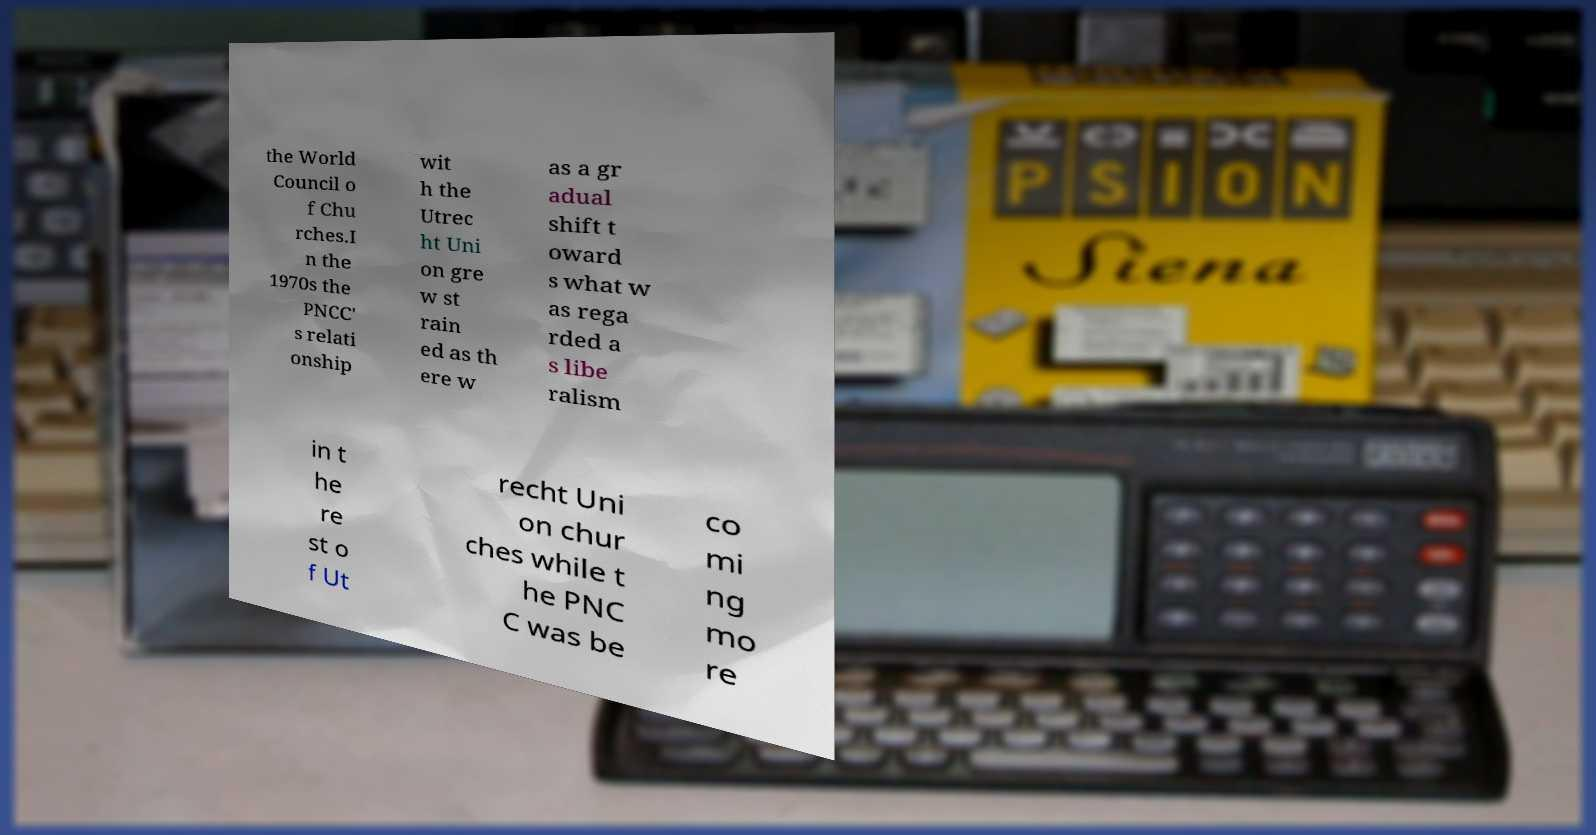For documentation purposes, I need the text within this image transcribed. Could you provide that? the World Council o f Chu rches.I n the 1970s the PNCC' s relati onship wit h the Utrec ht Uni on gre w st rain ed as th ere w as a gr adual shift t oward s what w as rega rded a s libe ralism in t he re st o f Ut recht Uni on chur ches while t he PNC C was be co mi ng mo re 